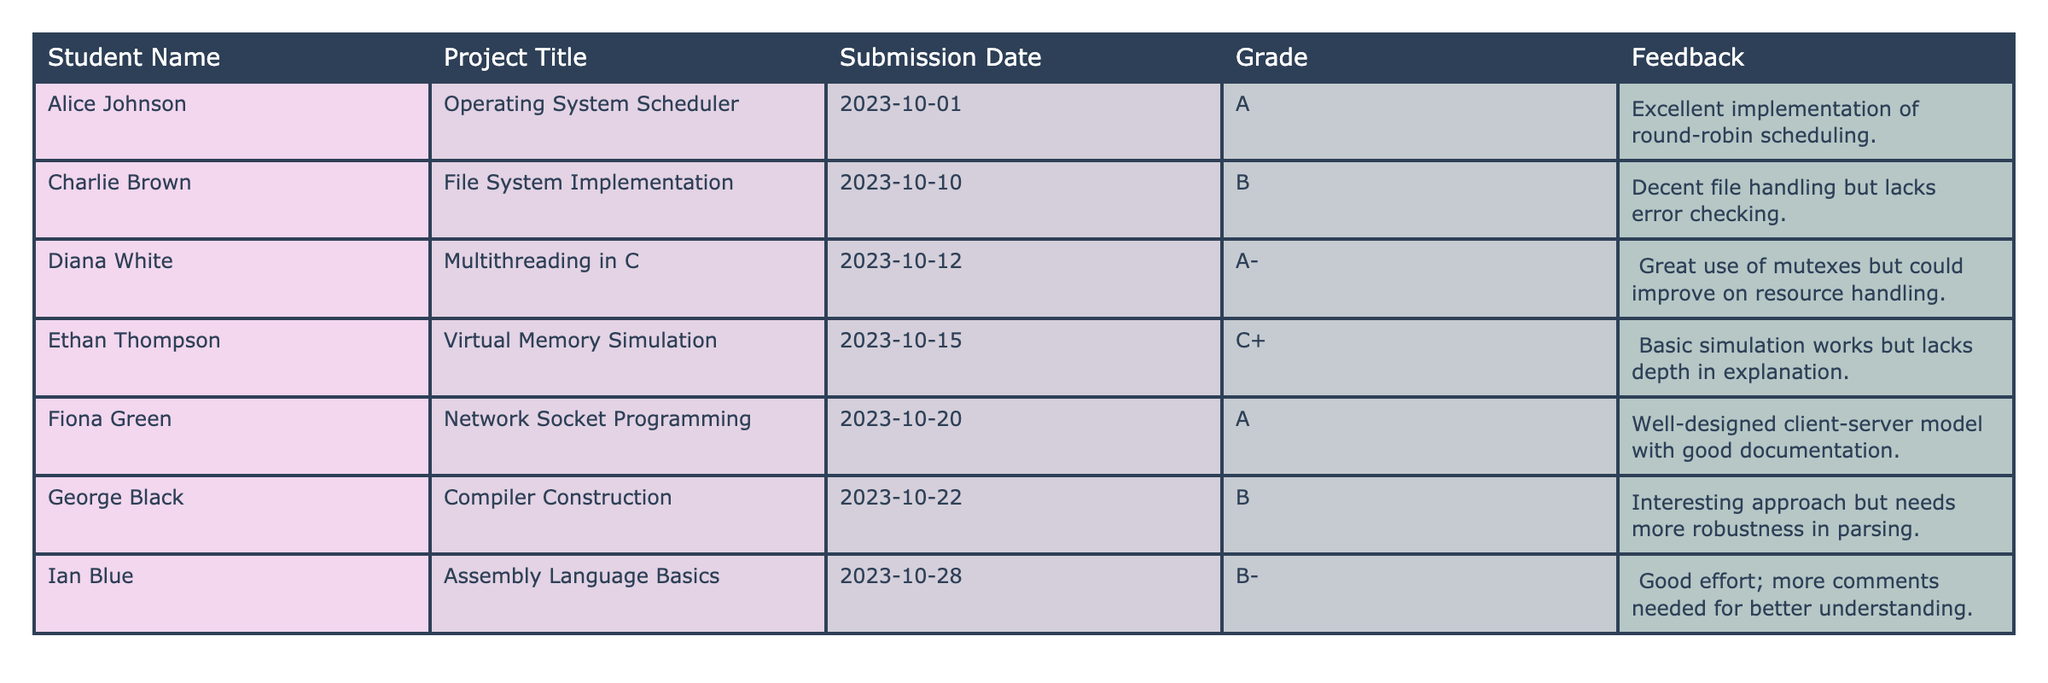What is the name of the student who submitted the "Network Socket Programming" project? The student's name is directly listed in the table under the "Student Name" column corresponding to the "Network Socket Programming" project title. It shows Fiona Green.
Answer: Fiona Green Which project received the lowest grade? The grades are listed in the "Grade" column, and by comparing the grades, "Assembly Language Basics" received the lowest grade of B-.
Answer: Assembly Language Basics How many projects received a grade of A? To find the answer, check the "Grade" column and count how many times 'A' appears. The projects "Operating System Scheduler" and "Network Socket Programming" received an A, totaling 2 projects.
Answer: 2 What feedback was given for the project "File System Implementation"? The feedback for "File System Implementation," found in the "Feedback" column, states: "Decent file handling but lacks error checking."
Answer: Decent file handling but lacks error checking Which student received the highest grade and what was the project title? The highest grade is 'A', which was awarded to two projects. Checking the table, "Operating System Scheduler" (by Alice Johnson) and "Network Socket Programming" (by Fiona Green) both received an A.
Answer: Alice Johnson, Operating System Scheduler / Fiona Green, Network Socket Programming What is the average grade of all submissions in the table? First, convert the letter grades into a numerical scale (A=4, A-=3.7, B=3, B-=2.7, C+=2). Calculate the average: (4 + 3.7 + 3 + 2.7 + 4 + 3 + 2.7) / 7 = 3.42. The average grade is approximately 3.4.
Answer: 3.4 Did any student receive feedback suggesting improvement in resource handling? Looking through the "Feedback" provided in the table, the response for "Multithreading in C" mentions improving resource handling, confirming that this is true.
Answer: Yes Which project submitted last received a grade of B-? The "Submission Date" column will help find the order of submissions. The last submission date is for "Assembly Language Basics," and it has a grade of B-.
Answer: Yes, Assembly Language Basics Find the student with a grade of C+ and what project did they submit? The "Grade" column identifies "Ethan Thompson" who submitted "Virtual Memory Simulation" as the only project with a C+.
Answer: Ethan Thompson, Virtual Memory Simulation Is there any feedback provided for projects that rated below B? By reviewing the "Feedback" column for grades below B (C+ and B-), the feedback for "Virtual Memory Simulation" and "Assembly Language Basics" is indeed present, indicating that the answer is true.
Answer: Yes 